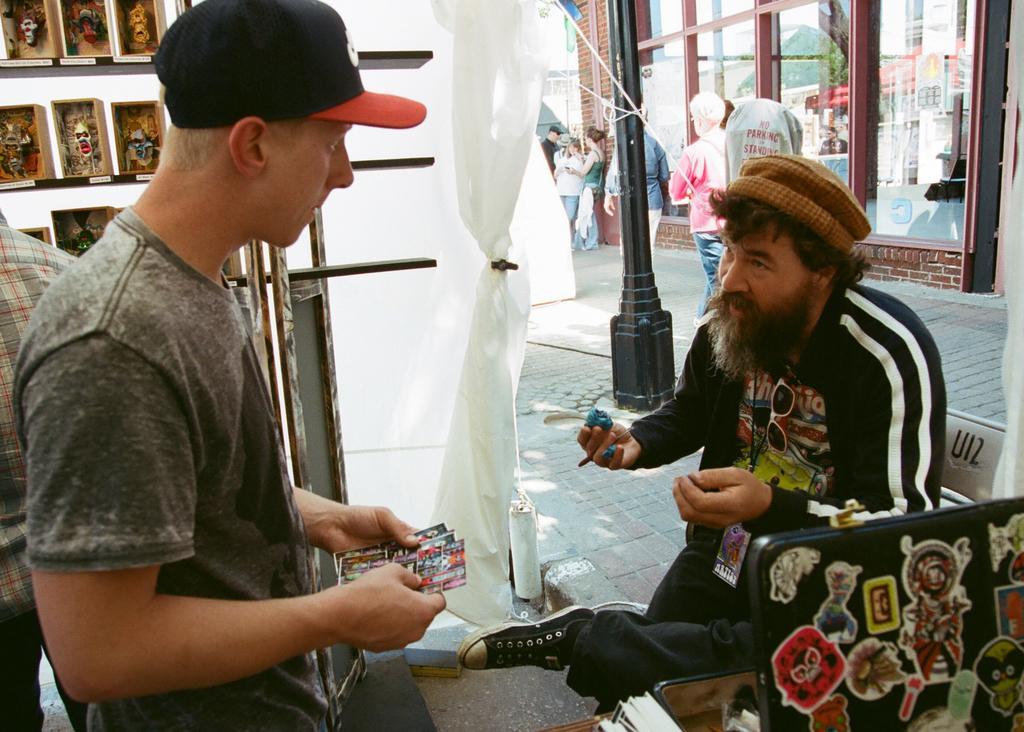Describe this image in one or two sentences. In this image, we can see two people are holding some objects and looking at each other. On the right side, a person is sitting. At the bottom, there is a black color object with so many stickers on it. Background we can see cover, few objects and people. There is a black pole, walkway and house with glass windows. Few people are walking on the walkway. Few people are standing near the house. 